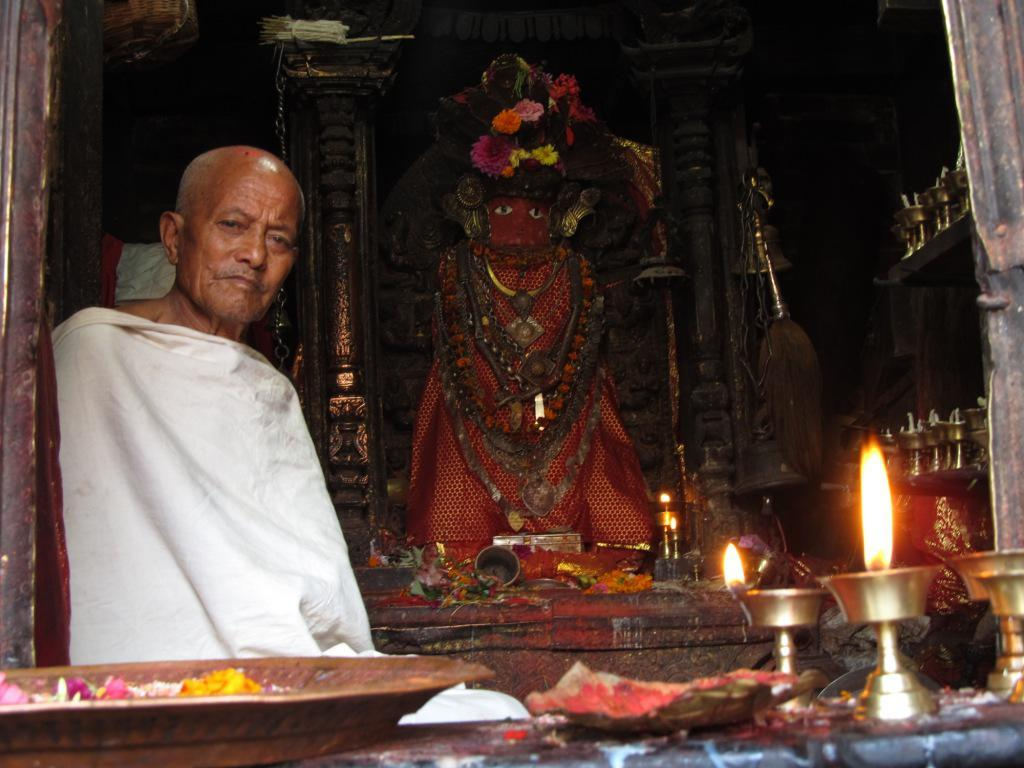What is the man in the image doing? There is a man sitting in the image. What other notable object can be seen in the image? There is a statue in the image. What type of plants are present in the image? There are flowers in the image. What type of lighting is present in the image? There are samai oil lamps in the image. Can you describe any other objects present in the image? There are other objects present in the image, but their specific details are not mentioned in the provided facts. What type of balls are being used to treat the man's throat in the image? There is no mention of balls or a throat issue in the image. The image features a man sitting, a statue, flowers, samai oil lamps, and other unspecified objects. 